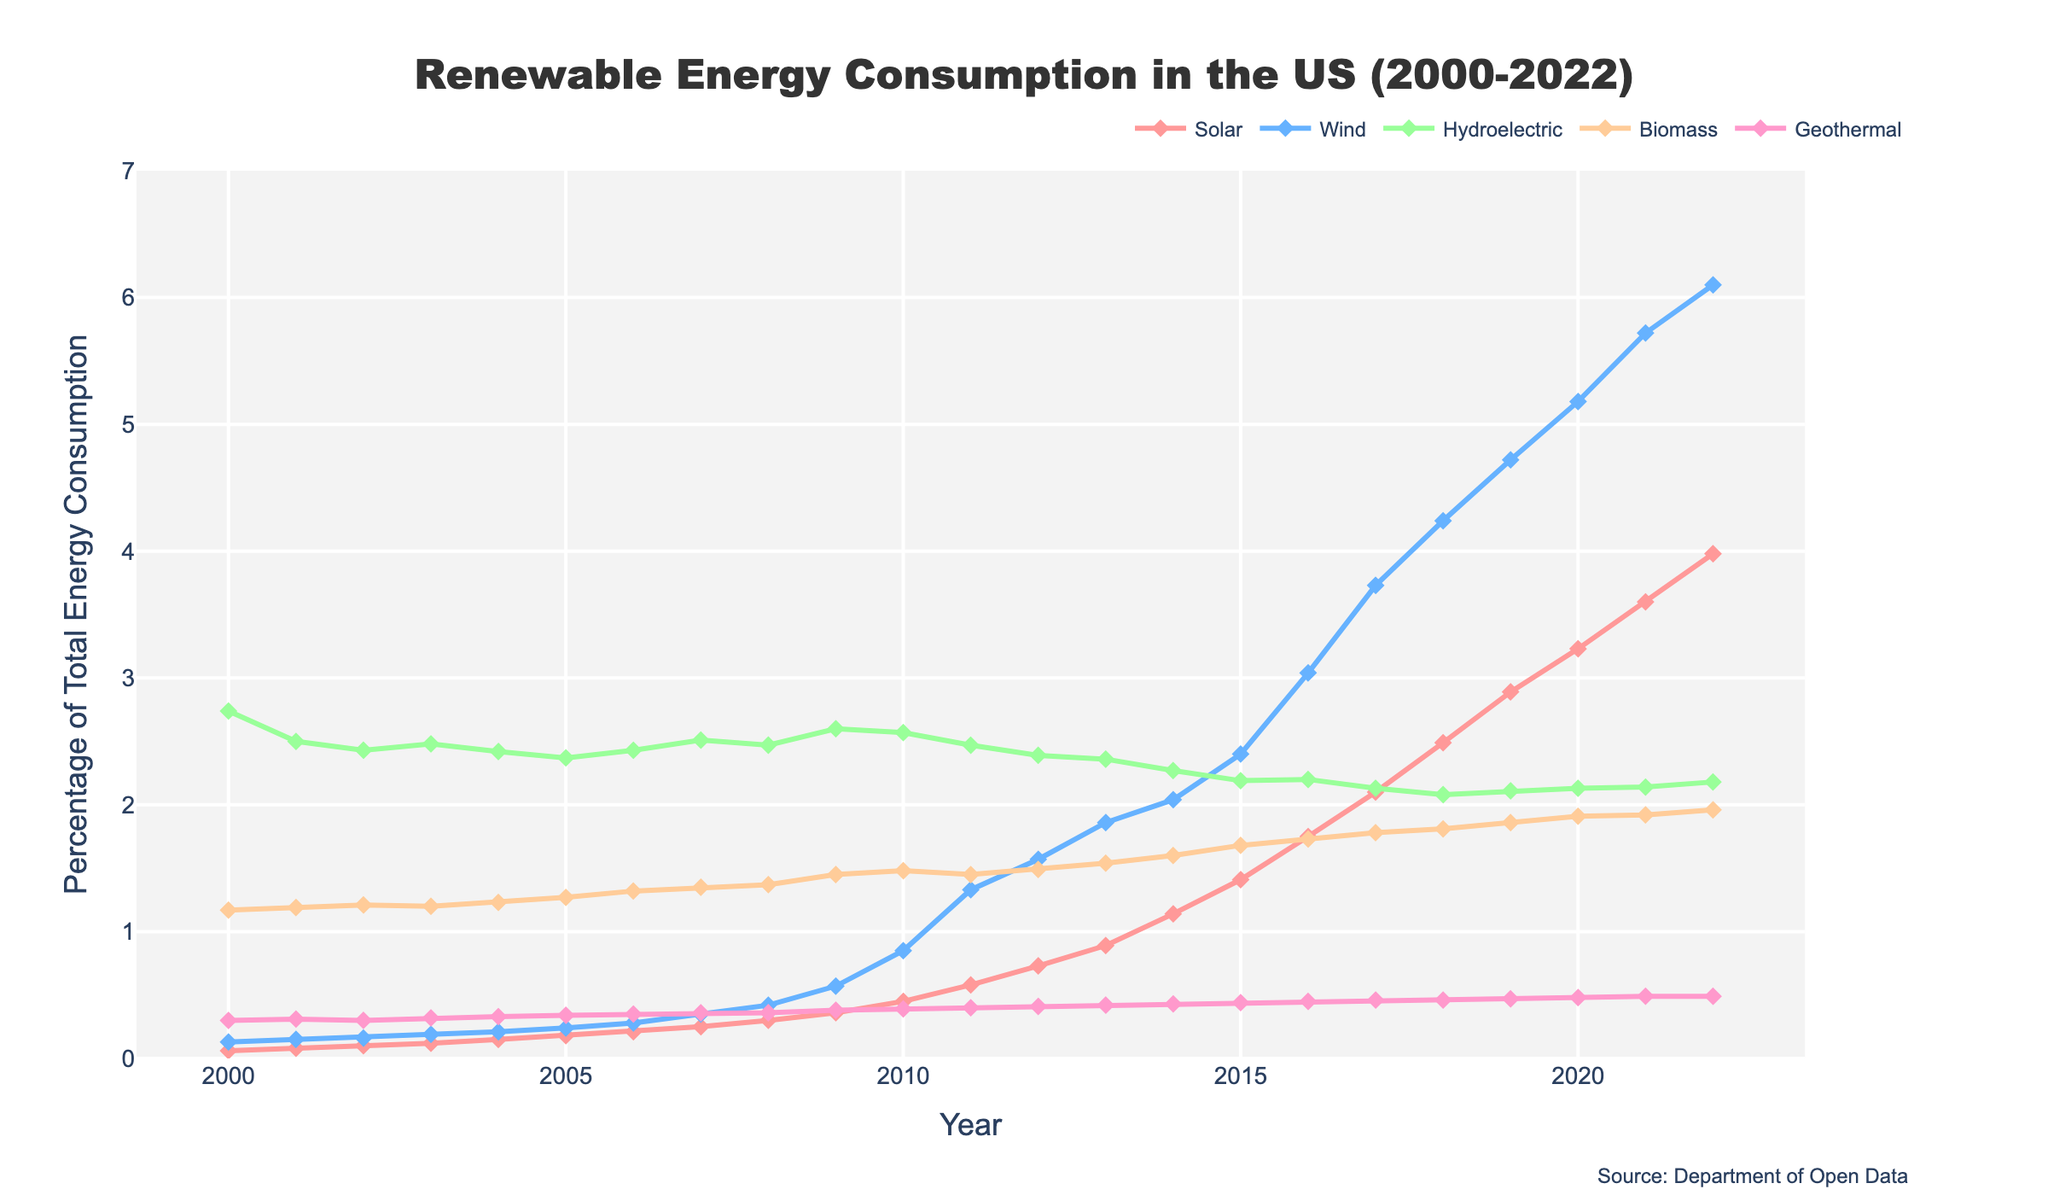What is the title of the figure? The title is located at the top center of the figure and reads "Renewable Energy Consumption in the US (2000-2022)"
Answer: Renewable Energy Consumption in the US (2000-2022) How many different types of renewable energy sources are represented in the figure? By looking at the legend, you can count the number of distinct energy sources listed, which are Solar, Wind, Hydroelectric, Biomass, and Geothermal
Answer: 5 Which renewable energy source saw the most significant increase in percentage consumption from 2000 to 2022? By plotting each line's overall slope, you can see that the Wind energy line has the steepest positive slope, indicating the most significant increase
Answer: Wind In which year did solar energy consumption exceed 2% for the first time? By tracing the Solar line from left to right, you see that it first crosses the 2% mark between 2015 and 2016
Answer: 2017 What is the range of percentages displayed on the Y-axis? By looking at the Y-axis values on the left side of the figure, you can see it ranges from 0 to 7%
Answer: 0 to 7% Compare the percentage consumption of hydroelectric energy in 2000 and 2022. How much did it change? In 2000, hydroelectric consumption is 2.74% and in 2022 it is 2.18%. The change is 2.18 - 2.74 = -0.56
Answer: -0.56 Which energy source had the smallest fluctuation in percentage consumption over the years? By comparing the lines, the flattest line would correspond to the smallest fluctuation. Geothermal shows the least variation over the years
Answer: Geothermal Were there any years where biomass energy consumption decreased compared to the previous year? By examining the line for Biomass, you can see there are no points where the line drops from year to year
Answer: No From 2000 to 2022, which energy source has consistently increased every year? By closely observing the trends in each energy source, you'll find that Solar consistently shows an upward trend every year
Answer: Solar What was the combined percentage of all renewable energy consumption in 2020? Sum the percentages for Solar, Wind, Hydroelectric, Biomass, and Geothermal in 2020: 3.23 + 5.18 + 2.13 + 1.91 + 0.48 = 12.93
Answer: 12.93 